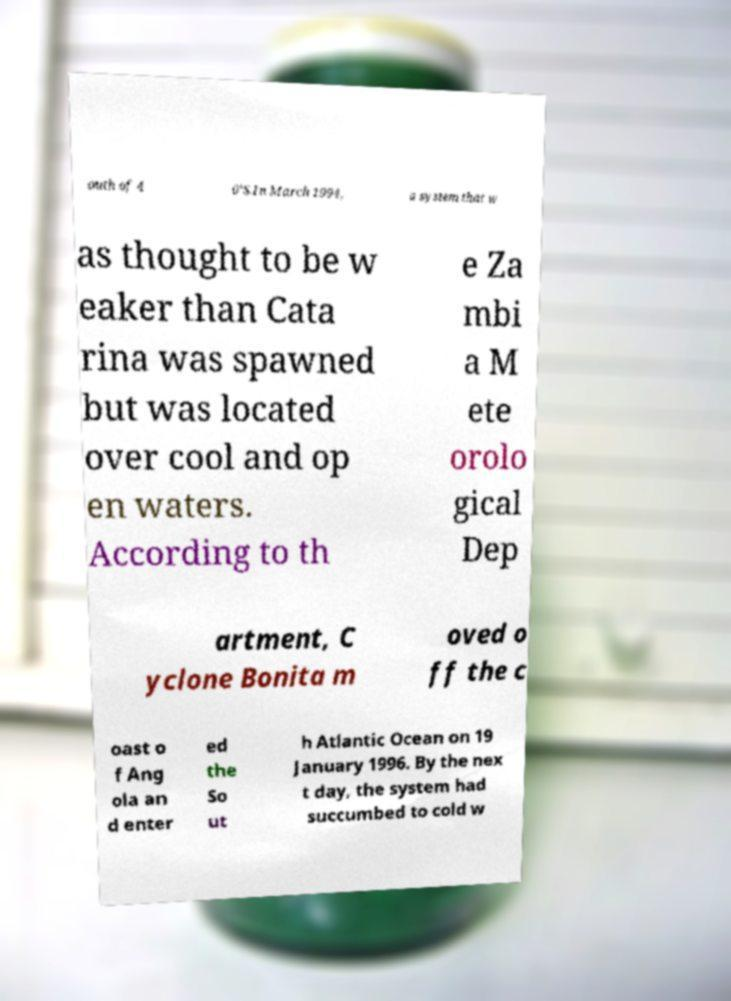What messages or text are displayed in this image? I need them in a readable, typed format. outh of 4 0°S.In March 1994, a system that w as thought to be w eaker than Cata rina was spawned but was located over cool and op en waters. According to th e Za mbi a M ete orolo gical Dep artment, C yclone Bonita m oved o ff the c oast o f Ang ola an d enter ed the So ut h Atlantic Ocean on 19 January 1996. By the nex t day, the system had succumbed to cold w 